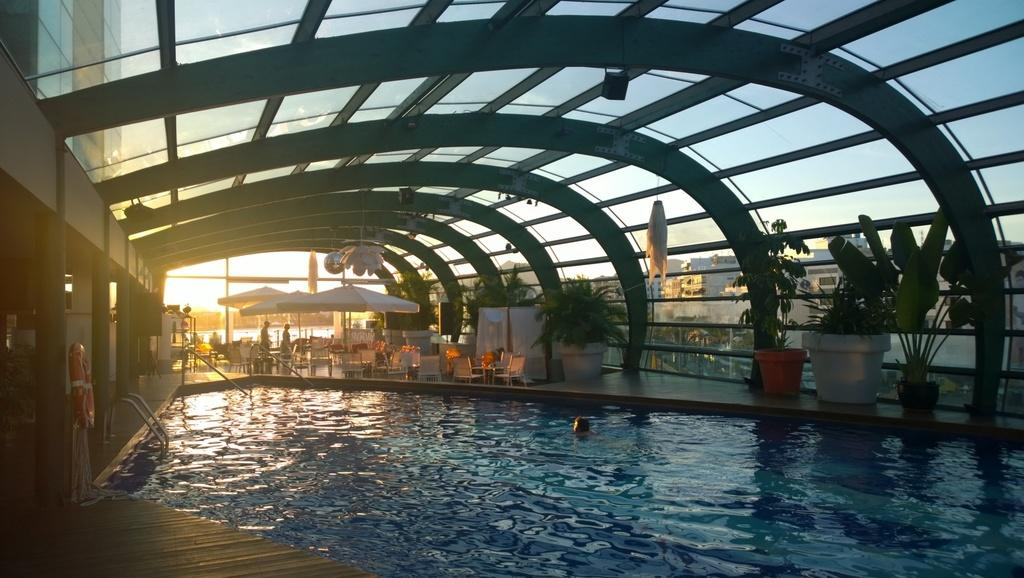What type of structure can be seen in the image? There is a building in the image. What recreational feature is present in the image? There is a swimming pool in the image. What are the people in the image doing? There are persons standing on the floor in the image. What type of furniture is present in the image? There are tables and chairs in the image. What type of shade is provided in the image? There are parasols in the image. What type of lighting is present in the image? There are lights in the image. What type of greenery is present in the image? There are houseplants in the image. What can be seen in the background of the image? There are buildings and the sky visible in the background of the image. What is the weather like in the image? The sky has clouds in it, suggesting a partly cloudy day. What type of company is operating in the room shown in the image? There is no room present in the image, only an outdoor area with a building, swimming pool, and other features. What sense is being stimulated by the houseplants in the image? The provided facts do not specify which sense is being stimulated by the houseplants; they only mention their presence. 